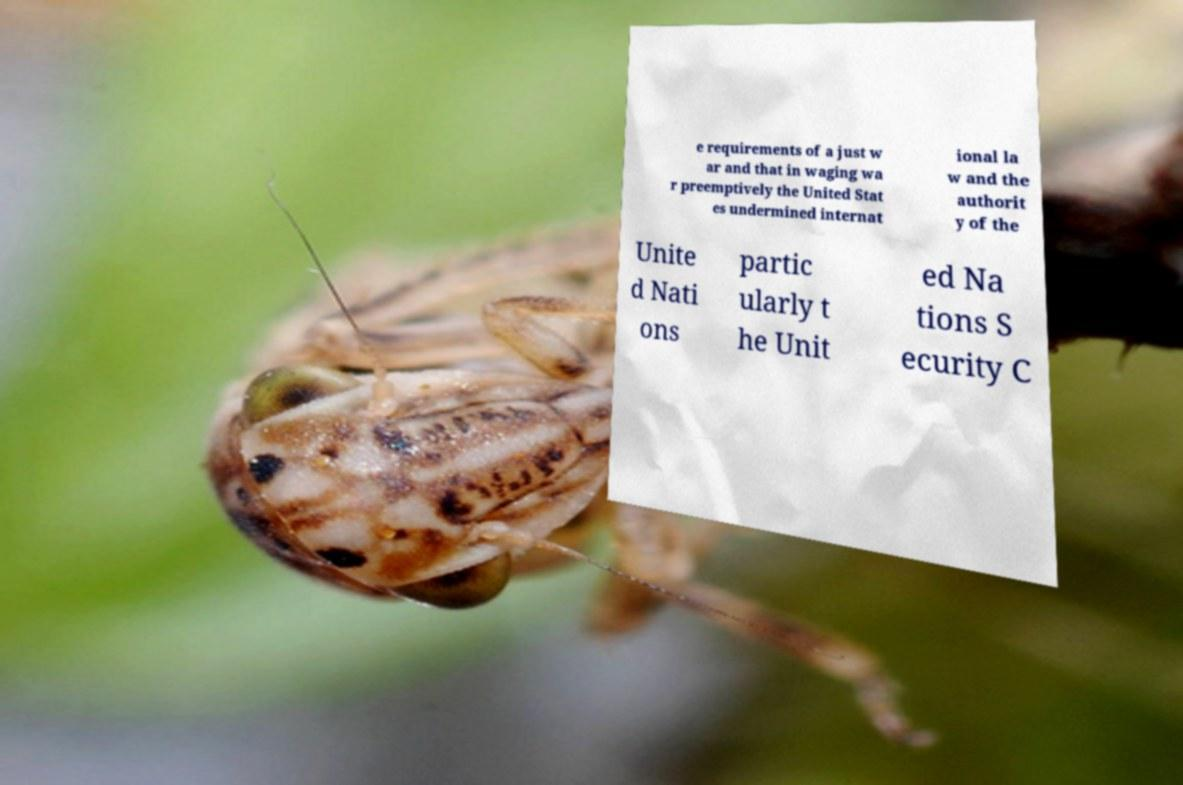Can you accurately transcribe the text from the provided image for me? e requirements of a just w ar and that in waging wa r preemptively the United Stat es undermined internat ional la w and the authorit y of the Unite d Nati ons partic ularly t he Unit ed Na tions S ecurity C 